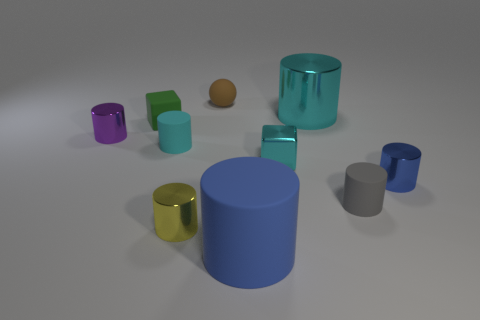Subtract all small shiny cylinders. How many cylinders are left? 4 Subtract all green cubes. How many cubes are left? 1 Subtract 1 spheres. How many spheres are left? 0 Add 4 tiny purple objects. How many tiny purple objects are left? 5 Add 4 tiny yellow metal things. How many tiny yellow metal things exist? 5 Subtract 0 gray cubes. How many objects are left? 10 Subtract all cylinders. How many objects are left? 3 Subtract all cyan cylinders. Subtract all brown balls. How many cylinders are left? 5 Subtract all purple cylinders. How many cyan blocks are left? 1 Subtract all small rubber cubes. Subtract all small green rubber objects. How many objects are left? 8 